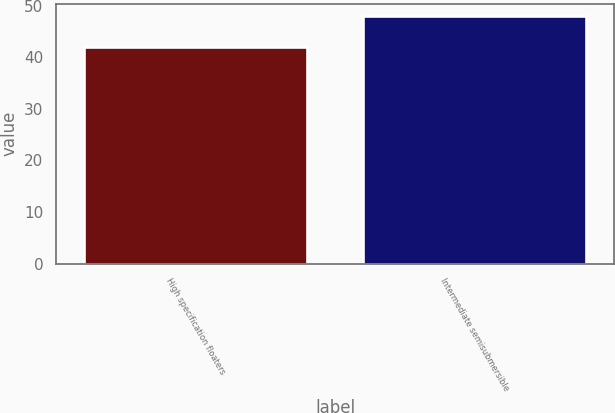Convert chart. <chart><loc_0><loc_0><loc_500><loc_500><bar_chart><fcel>High specification floaters<fcel>Intermediate semisubmersible<nl><fcel>42<fcel>48<nl></chart> 